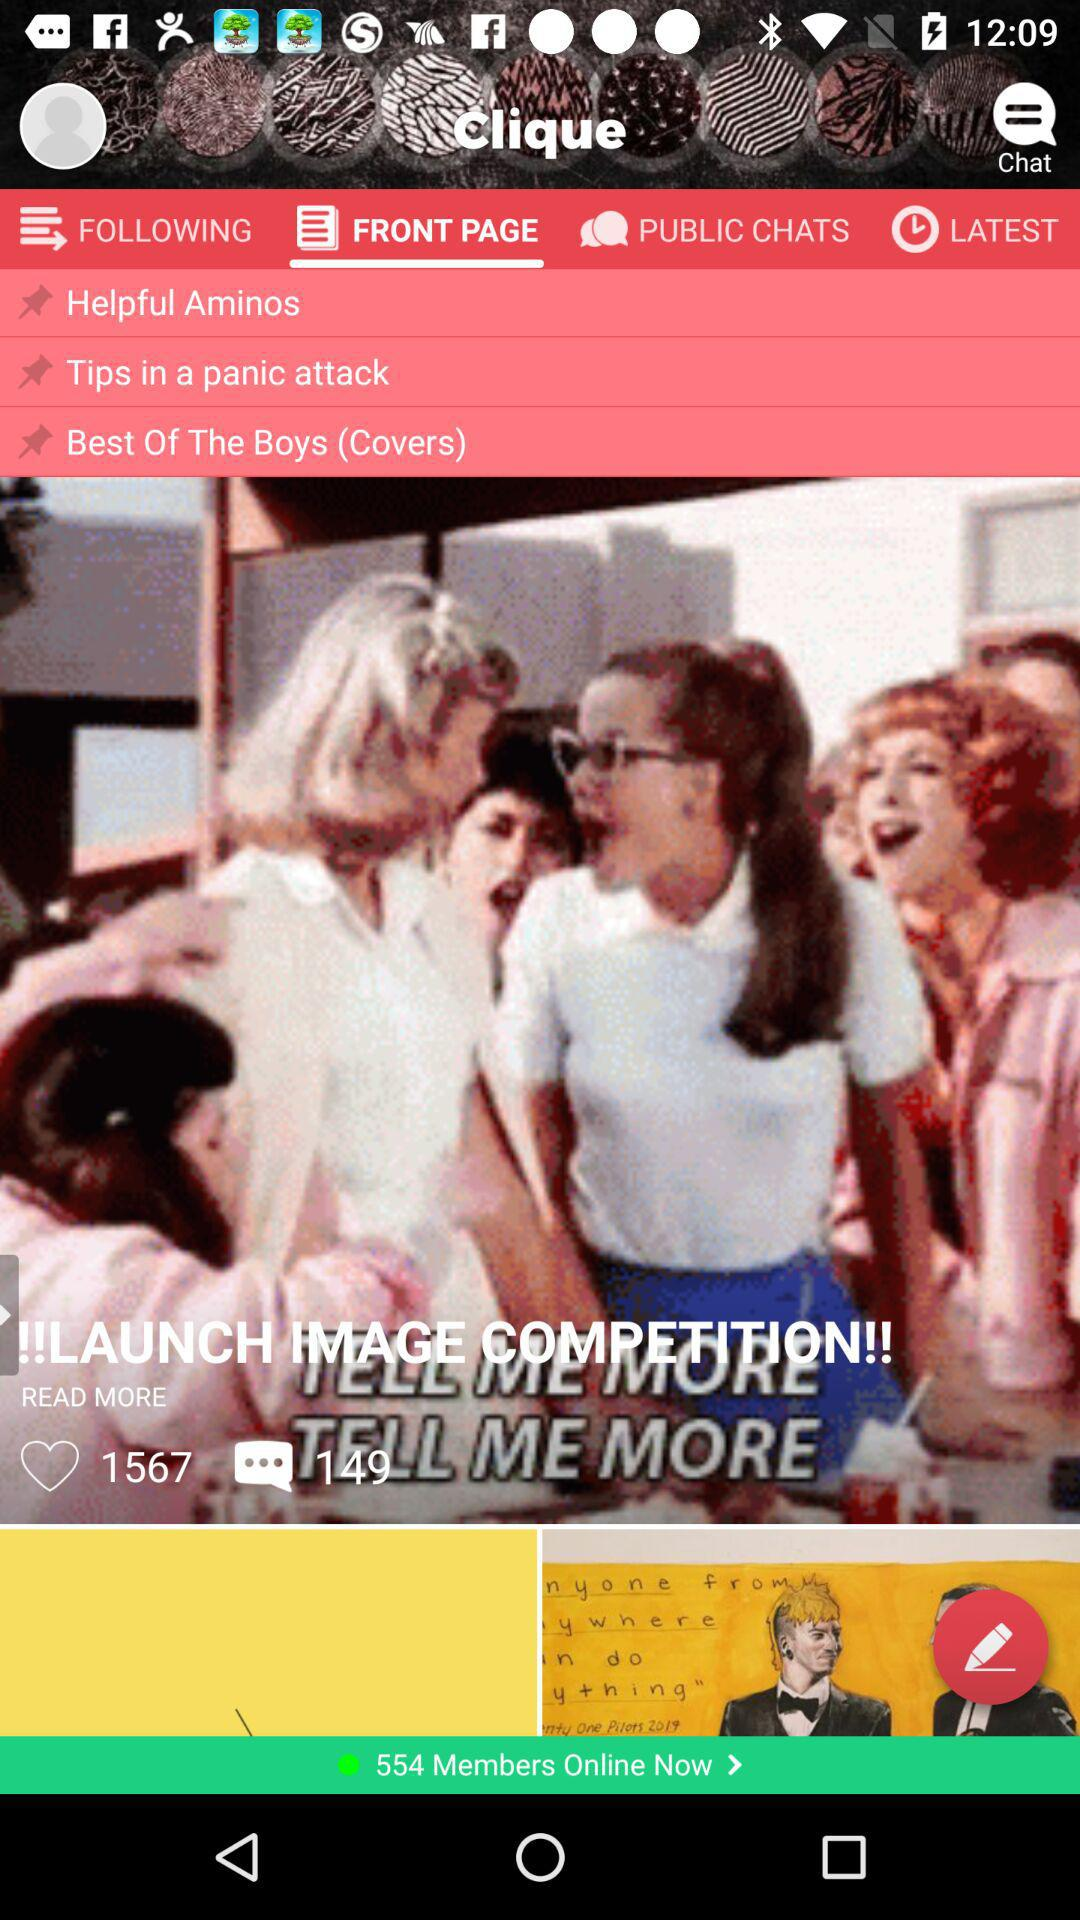How many likes are there? There are 1567 likes. 